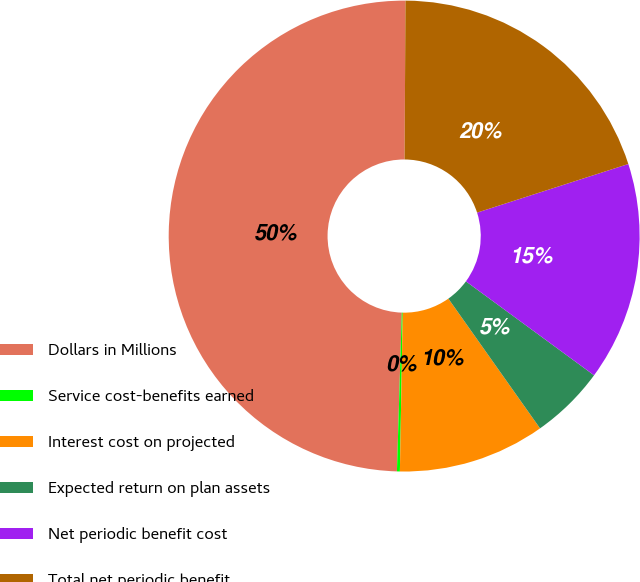<chart> <loc_0><loc_0><loc_500><loc_500><pie_chart><fcel>Dollars in Millions<fcel>Service cost-benefits earned<fcel>Interest cost on projected<fcel>Expected return on plan assets<fcel>Net periodic benefit cost<fcel>Total net periodic benefit<nl><fcel>49.6%<fcel>0.2%<fcel>10.08%<fcel>5.14%<fcel>15.02%<fcel>19.96%<nl></chart> 